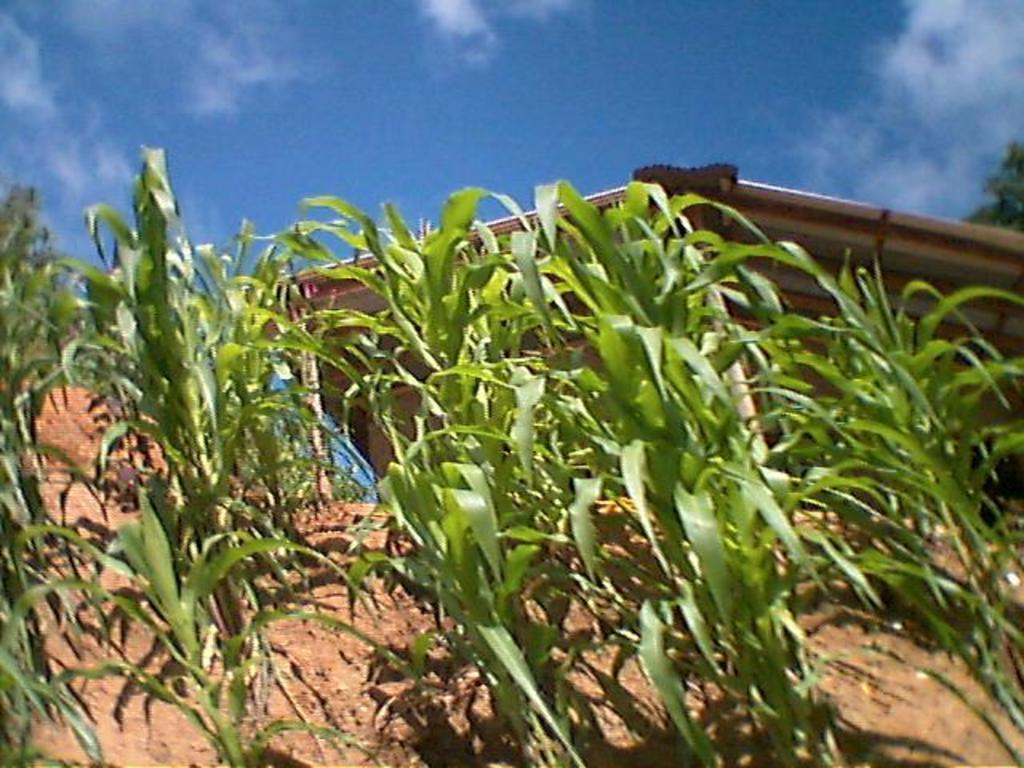What is located at the bottom of the picture? There are field crops and soil at the bottom of the picture. What can be seen behind the field crops and soil? There is a white object behind the field crops and soil. What is visible at the top of the picture? The sky is visible at the top of the picture. What is the color of the sky in the picture? The color of the sky is blue. What type of stone is being heated by the steam in the picture? There is no stone or steam present in the picture; it features field crops, soil, a white object, and a blue sky. What tin object is being used to collect the water from the field crops in the picture? There is no tin object or water collection process depicted in the image. 